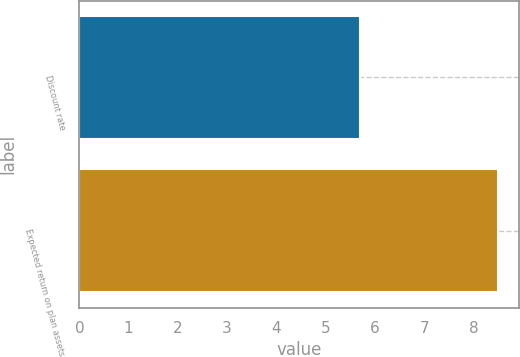<chart> <loc_0><loc_0><loc_500><loc_500><bar_chart><fcel>Discount rate<fcel>Expected return on plan assets<nl><fcel>5.69<fcel>8.5<nl></chart> 